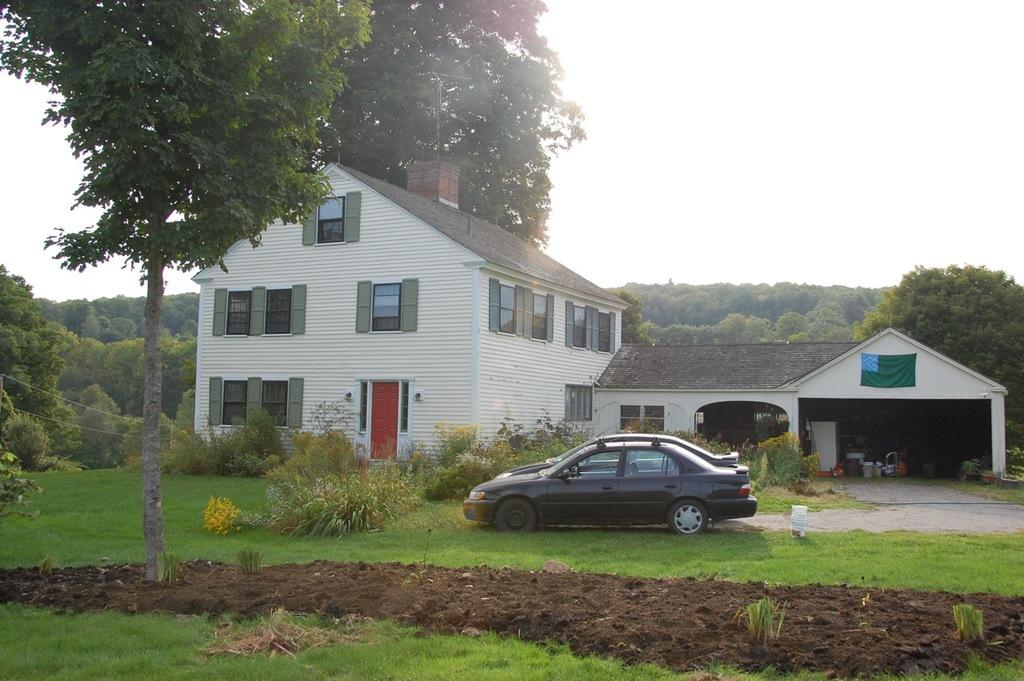What type of vegetation can be seen in the image? There are plants and grassland in the image. What type of vehicles are present in the image? There are cars in the image. What is located in the foreground of the image? There is a tree in the foreground of the image. What structures can be seen in the background of the image? There are houses and trees in the background of the image. What part of the natural environment is visible in the image? The sky is visible in the background of the image. What type of pain can be seen in the image? There is no pain present in the image; it features plants, grassland, cars, trees, houses, and the sky. What need is being addressed by the objects in the image? The objects in the image do not address any specific need; they are simply elements of the scene. 